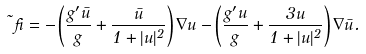Convert formula to latex. <formula><loc_0><loc_0><loc_500><loc_500>\vec { \beta } = - \left ( \frac { g ^ { \prime } \bar { u } } { g } + \frac { \bar { u } } { 1 + | u | ^ { 2 } } \right ) \nabla u - \left ( \frac { g ^ { \prime } u } { g } + \frac { 3 u } { 1 + | u | ^ { 2 } } \right ) \nabla \bar { u } .</formula> 